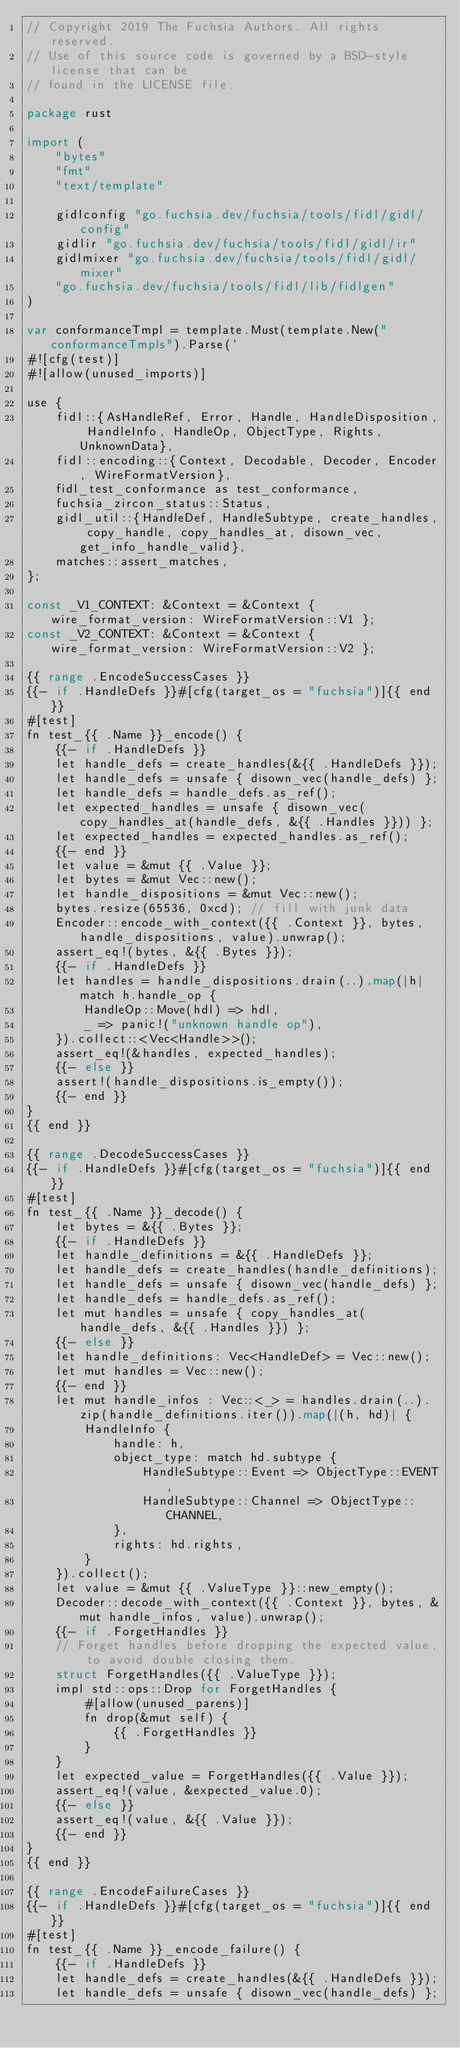Convert code to text. <code><loc_0><loc_0><loc_500><loc_500><_Go_>// Copyright 2019 The Fuchsia Authors. All rights reserved.
// Use of this source code is governed by a BSD-style license that can be
// found in the LICENSE file.

package rust

import (
	"bytes"
	"fmt"
	"text/template"

	gidlconfig "go.fuchsia.dev/fuchsia/tools/fidl/gidl/config"
	gidlir "go.fuchsia.dev/fuchsia/tools/fidl/gidl/ir"
	gidlmixer "go.fuchsia.dev/fuchsia/tools/fidl/gidl/mixer"
	"go.fuchsia.dev/fuchsia/tools/fidl/lib/fidlgen"
)

var conformanceTmpl = template.Must(template.New("conformanceTmpls").Parse(`
#![cfg(test)]
#![allow(unused_imports)]

use {
	fidl::{AsHandleRef, Error, Handle, HandleDisposition, HandleInfo, HandleOp, ObjectType, Rights, UnknownData},
	fidl::encoding::{Context, Decodable, Decoder, Encoder, WireFormatVersion},
	fidl_test_conformance as test_conformance,
	fuchsia_zircon_status::Status,
	gidl_util::{HandleDef, HandleSubtype, create_handles, copy_handle, copy_handles_at, disown_vec, get_info_handle_valid},
	matches::assert_matches,
};

const _V1_CONTEXT: &Context = &Context { wire_format_version: WireFormatVersion::V1 };
const _V2_CONTEXT: &Context = &Context { wire_format_version: WireFormatVersion::V2 };

{{ range .EncodeSuccessCases }}
{{- if .HandleDefs }}#[cfg(target_os = "fuchsia")]{{ end }}
#[test]
fn test_{{ .Name }}_encode() {
	{{- if .HandleDefs }}
	let handle_defs = create_handles(&{{ .HandleDefs }});
	let handle_defs = unsafe { disown_vec(handle_defs) };
	let handle_defs = handle_defs.as_ref();
	let expected_handles = unsafe { disown_vec(copy_handles_at(handle_defs, &{{ .Handles }})) };
	let expected_handles = expected_handles.as_ref();
	{{- end }}
	let value = &mut {{ .Value }};
	let bytes = &mut Vec::new();
	let handle_dispositions = &mut Vec::new();
	bytes.resize(65536, 0xcd); // fill with junk data
	Encoder::encode_with_context({{ .Context }}, bytes, handle_dispositions, value).unwrap();
	assert_eq!(bytes, &{{ .Bytes }});
	{{- if .HandleDefs }}
	let handles = handle_dispositions.drain(..).map(|h| match h.handle_op {
		HandleOp::Move(hdl) => hdl,
		_ => panic!("unknown handle op"),
	}).collect::<Vec<Handle>>();
	assert_eq!(&handles, expected_handles);
	{{- else }}
	assert!(handle_dispositions.is_empty());
	{{- end }}
}
{{ end }}

{{ range .DecodeSuccessCases }}
{{- if .HandleDefs }}#[cfg(target_os = "fuchsia")]{{ end }}
#[test]
fn test_{{ .Name }}_decode() {
	let bytes = &{{ .Bytes }};
	{{- if .HandleDefs }}
	let handle_definitions = &{{ .HandleDefs }};
	let handle_defs = create_handles(handle_definitions);
	let handle_defs = unsafe { disown_vec(handle_defs) };
	let handle_defs = handle_defs.as_ref();
	let mut handles = unsafe { copy_handles_at(handle_defs, &{{ .Handles }}) };
	{{- else }}
	let handle_definitions: Vec<HandleDef> = Vec::new();
	let mut handles = Vec::new();
	{{- end }}
	let mut handle_infos : Vec::<_> = handles.drain(..).zip(handle_definitions.iter()).map(|(h, hd)| {
		HandleInfo {
			handle: h,
			object_type: match hd.subtype {
				HandleSubtype::Event => ObjectType::EVENT,
				HandleSubtype::Channel => ObjectType::CHANNEL,
			},
			rights: hd.rights,
		}
	}).collect();
	let value = &mut {{ .ValueType }}::new_empty();
	Decoder::decode_with_context({{ .Context }}, bytes, &mut handle_infos, value).unwrap();
	{{- if .ForgetHandles }}
	// Forget handles before dropping the expected value, to avoid double closing them.
	struct ForgetHandles({{ .ValueType }});
	impl std::ops::Drop for ForgetHandles {
		#[allow(unused_parens)]
		fn drop(&mut self) {
			{{ .ForgetHandles }}
		}
	}
	let expected_value = ForgetHandles({{ .Value }});
	assert_eq!(value, &expected_value.0);
	{{- else }}
	assert_eq!(value, &{{ .Value }});
	{{- end }}
}
{{ end }}

{{ range .EncodeFailureCases }}
{{- if .HandleDefs }}#[cfg(target_os = "fuchsia")]{{ end }}
#[test]
fn test_{{ .Name }}_encode_failure() {
	{{- if .HandleDefs }}
	let handle_defs = create_handles(&{{ .HandleDefs }});
	let handle_defs = unsafe { disown_vec(handle_defs) };</code> 